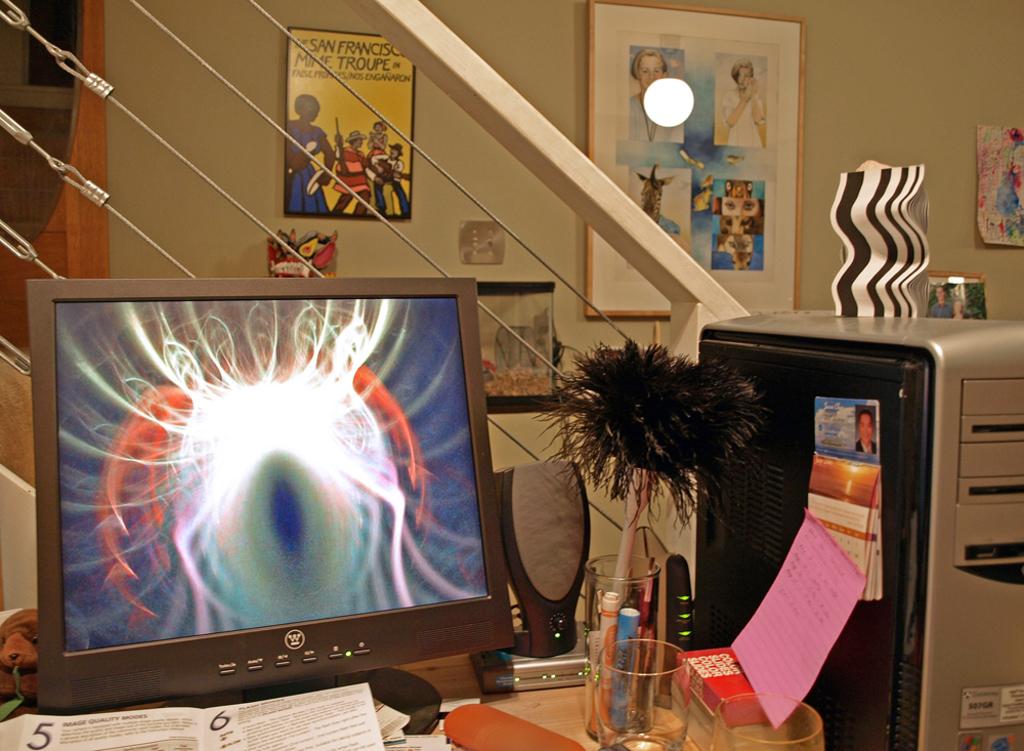What numbers are on the book pages?
Your answer should be compact. 5 6. 